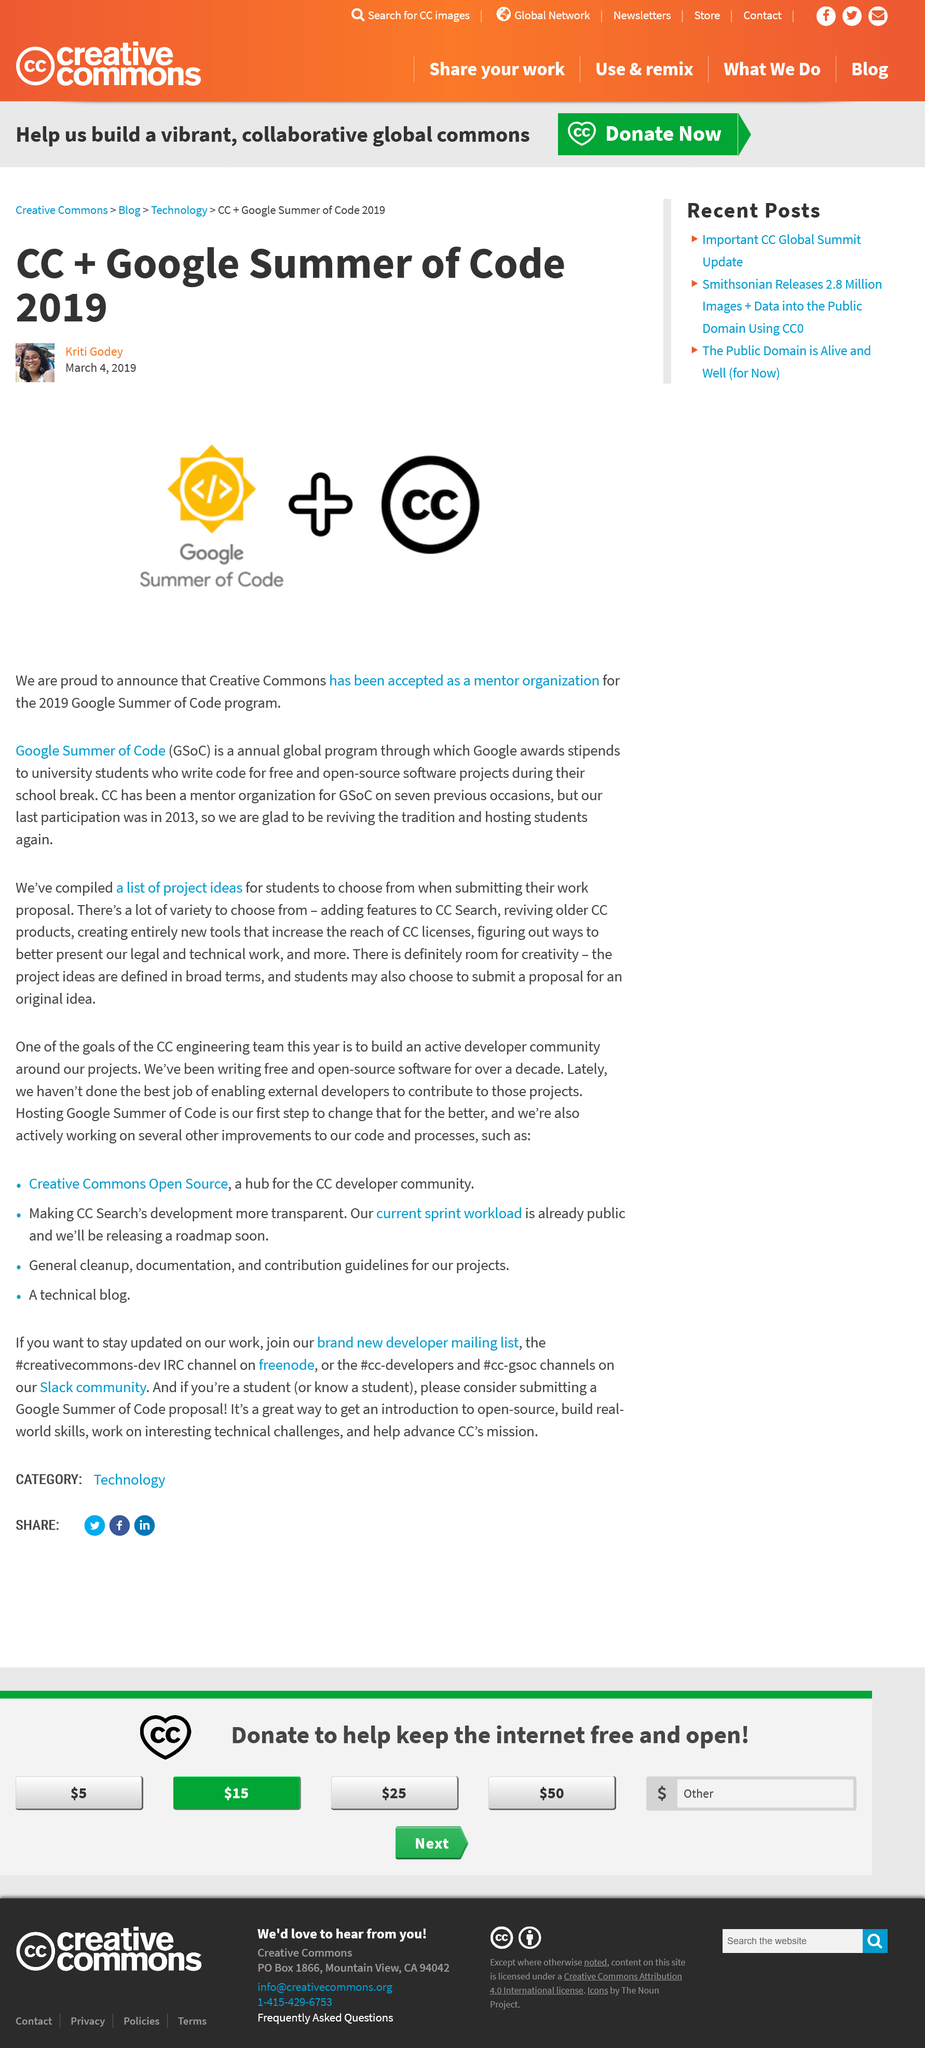Give some essential details in this illustration. The author of this article is Kriti Godey. This article was written on March 4, 2019. The acronym "GSoC" stands for "Google Summer of Code," a program developed by Google to provide students with an opportunity to participate in a three-month mentored development program during the summer, focused on open-source software projects. 